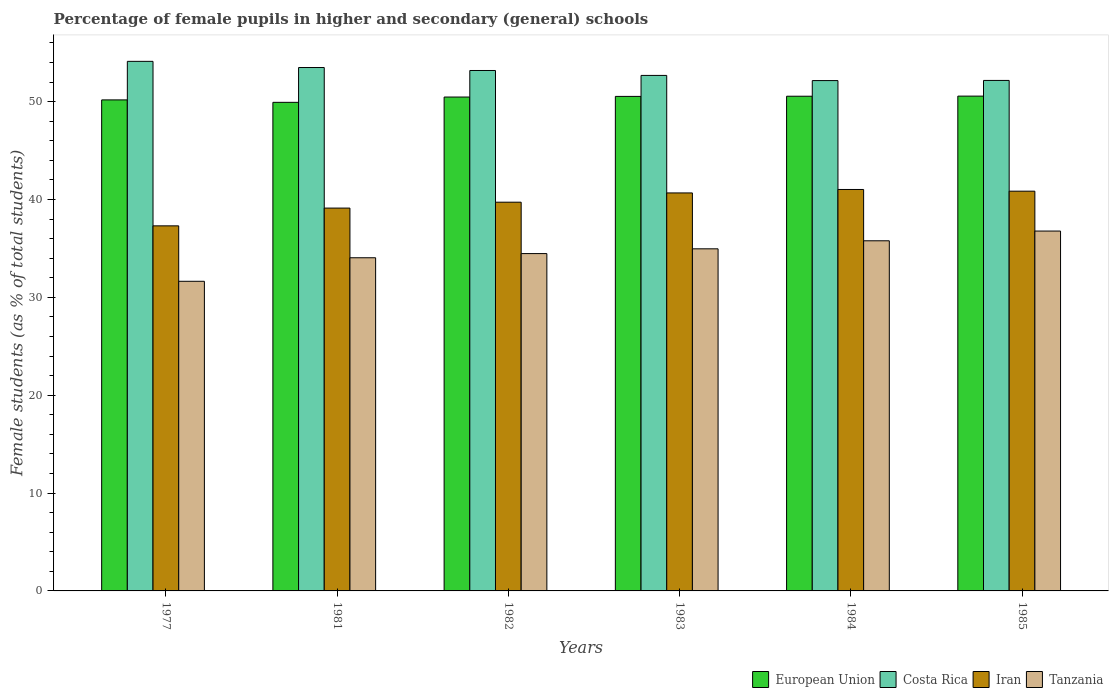How many different coloured bars are there?
Your answer should be very brief. 4. How many groups of bars are there?
Offer a terse response. 6. Are the number of bars on each tick of the X-axis equal?
Your answer should be compact. Yes. How many bars are there on the 6th tick from the right?
Provide a succinct answer. 4. What is the label of the 2nd group of bars from the left?
Keep it short and to the point. 1981. In how many cases, is the number of bars for a given year not equal to the number of legend labels?
Provide a short and direct response. 0. What is the percentage of female pupils in higher and secondary schools in Iran in 1982?
Offer a very short reply. 39.72. Across all years, what is the maximum percentage of female pupils in higher and secondary schools in Costa Rica?
Provide a short and direct response. 54.11. Across all years, what is the minimum percentage of female pupils in higher and secondary schools in Tanzania?
Provide a short and direct response. 31.64. In which year was the percentage of female pupils in higher and secondary schools in Iran maximum?
Your answer should be very brief. 1984. What is the total percentage of female pupils in higher and secondary schools in Costa Rica in the graph?
Offer a very short reply. 317.77. What is the difference between the percentage of female pupils in higher and secondary schools in Tanzania in 1977 and that in 1981?
Your answer should be compact. -2.41. What is the difference between the percentage of female pupils in higher and secondary schools in Costa Rica in 1985 and the percentage of female pupils in higher and secondary schools in Iran in 1984?
Ensure brevity in your answer.  11.14. What is the average percentage of female pupils in higher and secondary schools in Costa Rica per year?
Provide a succinct answer. 52.96. In the year 1981, what is the difference between the percentage of female pupils in higher and secondary schools in European Union and percentage of female pupils in higher and secondary schools in Iran?
Your response must be concise. 10.81. What is the ratio of the percentage of female pupils in higher and secondary schools in Iran in 1982 to that in 1985?
Offer a terse response. 0.97. Is the percentage of female pupils in higher and secondary schools in Iran in 1981 less than that in 1985?
Your answer should be very brief. Yes. Is the difference between the percentage of female pupils in higher and secondary schools in European Union in 1981 and 1985 greater than the difference between the percentage of female pupils in higher and secondary schools in Iran in 1981 and 1985?
Keep it short and to the point. Yes. What is the difference between the highest and the second highest percentage of female pupils in higher and secondary schools in Iran?
Offer a very short reply. 0.17. What is the difference between the highest and the lowest percentage of female pupils in higher and secondary schools in European Union?
Give a very brief answer. 0.63. In how many years, is the percentage of female pupils in higher and secondary schools in Iran greater than the average percentage of female pupils in higher and secondary schools in Iran taken over all years?
Make the answer very short. 3. Is the sum of the percentage of female pupils in higher and secondary schools in Costa Rica in 1983 and 1985 greater than the maximum percentage of female pupils in higher and secondary schools in Tanzania across all years?
Provide a short and direct response. Yes. What does the 3rd bar from the left in 1981 represents?
Your answer should be compact. Iran. What does the 1st bar from the right in 1982 represents?
Ensure brevity in your answer.  Tanzania. Is it the case that in every year, the sum of the percentage of female pupils in higher and secondary schools in Costa Rica and percentage of female pupils in higher and secondary schools in Iran is greater than the percentage of female pupils in higher and secondary schools in European Union?
Keep it short and to the point. Yes. Are all the bars in the graph horizontal?
Provide a short and direct response. No. What is the difference between two consecutive major ticks on the Y-axis?
Your answer should be very brief. 10. Are the values on the major ticks of Y-axis written in scientific E-notation?
Provide a succinct answer. No. Does the graph contain grids?
Provide a short and direct response. No. How many legend labels are there?
Offer a terse response. 4. How are the legend labels stacked?
Your answer should be compact. Horizontal. What is the title of the graph?
Offer a terse response. Percentage of female pupils in higher and secondary (general) schools. Does "Romania" appear as one of the legend labels in the graph?
Provide a succinct answer. No. What is the label or title of the Y-axis?
Ensure brevity in your answer.  Female students (as % of total students). What is the Female students (as % of total students) of European Union in 1977?
Your answer should be very brief. 50.18. What is the Female students (as % of total students) in Costa Rica in 1977?
Your response must be concise. 54.11. What is the Female students (as % of total students) of Iran in 1977?
Give a very brief answer. 37.3. What is the Female students (as % of total students) in Tanzania in 1977?
Offer a terse response. 31.64. What is the Female students (as % of total students) in European Union in 1981?
Provide a short and direct response. 49.93. What is the Female students (as % of total students) of Costa Rica in 1981?
Offer a terse response. 53.48. What is the Female students (as % of total students) of Iran in 1981?
Make the answer very short. 39.12. What is the Female students (as % of total students) in Tanzania in 1981?
Ensure brevity in your answer.  34.04. What is the Female students (as % of total students) in European Union in 1982?
Provide a succinct answer. 50.47. What is the Female students (as % of total students) of Costa Rica in 1982?
Your answer should be compact. 53.18. What is the Female students (as % of total students) of Iran in 1982?
Your answer should be very brief. 39.72. What is the Female students (as % of total students) in Tanzania in 1982?
Offer a terse response. 34.47. What is the Female students (as % of total students) of European Union in 1983?
Offer a very short reply. 50.53. What is the Female students (as % of total students) of Costa Rica in 1983?
Keep it short and to the point. 52.68. What is the Female students (as % of total students) in Iran in 1983?
Offer a terse response. 40.67. What is the Female students (as % of total students) of Tanzania in 1983?
Provide a succinct answer. 34.96. What is the Female students (as % of total students) of European Union in 1984?
Offer a very short reply. 50.55. What is the Female students (as % of total students) in Costa Rica in 1984?
Your answer should be very brief. 52.15. What is the Female students (as % of total students) of Iran in 1984?
Ensure brevity in your answer.  41.02. What is the Female students (as % of total students) in Tanzania in 1984?
Your answer should be very brief. 35.78. What is the Female students (as % of total students) of European Union in 1985?
Your answer should be very brief. 50.56. What is the Female students (as % of total students) of Costa Rica in 1985?
Keep it short and to the point. 52.16. What is the Female students (as % of total students) of Iran in 1985?
Provide a succinct answer. 40.85. What is the Female students (as % of total students) of Tanzania in 1985?
Your response must be concise. 36.77. Across all years, what is the maximum Female students (as % of total students) in European Union?
Provide a short and direct response. 50.56. Across all years, what is the maximum Female students (as % of total students) in Costa Rica?
Keep it short and to the point. 54.11. Across all years, what is the maximum Female students (as % of total students) in Iran?
Keep it short and to the point. 41.02. Across all years, what is the maximum Female students (as % of total students) in Tanzania?
Give a very brief answer. 36.77. Across all years, what is the minimum Female students (as % of total students) in European Union?
Your response must be concise. 49.93. Across all years, what is the minimum Female students (as % of total students) of Costa Rica?
Keep it short and to the point. 52.15. Across all years, what is the minimum Female students (as % of total students) of Iran?
Provide a short and direct response. 37.3. Across all years, what is the minimum Female students (as % of total students) in Tanzania?
Make the answer very short. 31.64. What is the total Female students (as % of total students) in European Union in the graph?
Ensure brevity in your answer.  302.22. What is the total Female students (as % of total students) of Costa Rica in the graph?
Make the answer very short. 317.77. What is the total Female students (as % of total students) in Iran in the graph?
Your response must be concise. 238.68. What is the total Female students (as % of total students) in Tanzania in the graph?
Keep it short and to the point. 207.67. What is the difference between the Female students (as % of total students) in European Union in 1977 and that in 1981?
Provide a short and direct response. 0.25. What is the difference between the Female students (as % of total students) of Costa Rica in 1977 and that in 1981?
Make the answer very short. 0.63. What is the difference between the Female students (as % of total students) of Iran in 1977 and that in 1981?
Your answer should be very brief. -1.82. What is the difference between the Female students (as % of total students) in Tanzania in 1977 and that in 1981?
Give a very brief answer. -2.41. What is the difference between the Female students (as % of total students) in European Union in 1977 and that in 1982?
Provide a succinct answer. -0.29. What is the difference between the Female students (as % of total students) of Costa Rica in 1977 and that in 1982?
Your answer should be compact. 0.93. What is the difference between the Female students (as % of total students) of Iran in 1977 and that in 1982?
Provide a succinct answer. -2.42. What is the difference between the Female students (as % of total students) of Tanzania in 1977 and that in 1982?
Offer a terse response. -2.83. What is the difference between the Female students (as % of total students) of European Union in 1977 and that in 1983?
Provide a short and direct response. -0.36. What is the difference between the Female students (as % of total students) in Costa Rica in 1977 and that in 1983?
Provide a short and direct response. 1.44. What is the difference between the Female students (as % of total students) in Iran in 1977 and that in 1983?
Offer a very short reply. -3.36. What is the difference between the Female students (as % of total students) of Tanzania in 1977 and that in 1983?
Your answer should be very brief. -3.32. What is the difference between the Female students (as % of total students) of European Union in 1977 and that in 1984?
Your answer should be compact. -0.38. What is the difference between the Female students (as % of total students) in Costa Rica in 1977 and that in 1984?
Provide a succinct answer. 1.96. What is the difference between the Female students (as % of total students) of Iran in 1977 and that in 1984?
Make the answer very short. -3.72. What is the difference between the Female students (as % of total students) in Tanzania in 1977 and that in 1984?
Your response must be concise. -4.14. What is the difference between the Female students (as % of total students) in European Union in 1977 and that in 1985?
Offer a very short reply. -0.39. What is the difference between the Female students (as % of total students) of Costa Rica in 1977 and that in 1985?
Offer a very short reply. 1.95. What is the difference between the Female students (as % of total students) in Iran in 1977 and that in 1985?
Ensure brevity in your answer.  -3.54. What is the difference between the Female students (as % of total students) of Tanzania in 1977 and that in 1985?
Your response must be concise. -5.13. What is the difference between the Female students (as % of total students) in European Union in 1981 and that in 1982?
Ensure brevity in your answer.  -0.54. What is the difference between the Female students (as % of total students) in Costa Rica in 1981 and that in 1982?
Ensure brevity in your answer.  0.3. What is the difference between the Female students (as % of total students) in Iran in 1981 and that in 1982?
Ensure brevity in your answer.  -0.6. What is the difference between the Female students (as % of total students) in Tanzania in 1981 and that in 1982?
Offer a terse response. -0.43. What is the difference between the Female students (as % of total students) in European Union in 1981 and that in 1983?
Provide a succinct answer. -0.61. What is the difference between the Female students (as % of total students) of Costa Rica in 1981 and that in 1983?
Offer a very short reply. 0.81. What is the difference between the Female students (as % of total students) in Iran in 1981 and that in 1983?
Your answer should be very brief. -1.55. What is the difference between the Female students (as % of total students) of Tanzania in 1981 and that in 1983?
Give a very brief answer. -0.91. What is the difference between the Female students (as % of total students) of European Union in 1981 and that in 1984?
Make the answer very short. -0.62. What is the difference between the Female students (as % of total students) of Costa Rica in 1981 and that in 1984?
Give a very brief answer. 1.33. What is the difference between the Female students (as % of total students) in Iran in 1981 and that in 1984?
Offer a terse response. -1.9. What is the difference between the Female students (as % of total students) in Tanzania in 1981 and that in 1984?
Your answer should be very brief. -1.73. What is the difference between the Female students (as % of total students) in European Union in 1981 and that in 1985?
Make the answer very short. -0.63. What is the difference between the Female students (as % of total students) in Costa Rica in 1981 and that in 1985?
Give a very brief answer. 1.32. What is the difference between the Female students (as % of total students) in Iran in 1981 and that in 1985?
Make the answer very short. -1.73. What is the difference between the Female students (as % of total students) of Tanzania in 1981 and that in 1985?
Your response must be concise. -2.73. What is the difference between the Female students (as % of total students) in European Union in 1982 and that in 1983?
Offer a terse response. -0.07. What is the difference between the Female students (as % of total students) in Costa Rica in 1982 and that in 1983?
Your answer should be compact. 0.5. What is the difference between the Female students (as % of total students) of Iran in 1982 and that in 1983?
Make the answer very short. -0.95. What is the difference between the Female students (as % of total students) of Tanzania in 1982 and that in 1983?
Make the answer very short. -0.49. What is the difference between the Female students (as % of total students) of European Union in 1982 and that in 1984?
Ensure brevity in your answer.  -0.08. What is the difference between the Female students (as % of total students) of Costa Rica in 1982 and that in 1984?
Provide a succinct answer. 1.03. What is the difference between the Female students (as % of total students) in Iran in 1982 and that in 1984?
Give a very brief answer. -1.3. What is the difference between the Female students (as % of total students) of Tanzania in 1982 and that in 1984?
Provide a short and direct response. -1.31. What is the difference between the Female students (as % of total students) of European Union in 1982 and that in 1985?
Offer a very short reply. -0.09. What is the difference between the Female students (as % of total students) in Costa Rica in 1982 and that in 1985?
Provide a succinct answer. 1.02. What is the difference between the Female students (as % of total students) in Iran in 1982 and that in 1985?
Your answer should be very brief. -1.12. What is the difference between the Female students (as % of total students) of Tanzania in 1982 and that in 1985?
Provide a short and direct response. -2.3. What is the difference between the Female students (as % of total students) of European Union in 1983 and that in 1984?
Keep it short and to the point. -0.02. What is the difference between the Female students (as % of total students) of Costa Rica in 1983 and that in 1984?
Provide a short and direct response. 0.53. What is the difference between the Female students (as % of total students) of Iran in 1983 and that in 1984?
Your answer should be very brief. -0.35. What is the difference between the Female students (as % of total students) in Tanzania in 1983 and that in 1984?
Your response must be concise. -0.82. What is the difference between the Female students (as % of total students) of European Union in 1983 and that in 1985?
Ensure brevity in your answer.  -0.03. What is the difference between the Female students (as % of total students) in Costa Rica in 1983 and that in 1985?
Your response must be concise. 0.51. What is the difference between the Female students (as % of total students) of Iran in 1983 and that in 1985?
Provide a succinct answer. -0.18. What is the difference between the Female students (as % of total students) in Tanzania in 1983 and that in 1985?
Ensure brevity in your answer.  -1.82. What is the difference between the Female students (as % of total students) in European Union in 1984 and that in 1985?
Provide a succinct answer. -0.01. What is the difference between the Female students (as % of total students) in Costa Rica in 1984 and that in 1985?
Ensure brevity in your answer.  -0.01. What is the difference between the Female students (as % of total students) of Iran in 1984 and that in 1985?
Your answer should be compact. 0.17. What is the difference between the Female students (as % of total students) in Tanzania in 1984 and that in 1985?
Provide a short and direct response. -0.99. What is the difference between the Female students (as % of total students) in European Union in 1977 and the Female students (as % of total students) in Costa Rica in 1981?
Give a very brief answer. -3.31. What is the difference between the Female students (as % of total students) in European Union in 1977 and the Female students (as % of total students) in Iran in 1981?
Offer a very short reply. 11.06. What is the difference between the Female students (as % of total students) of European Union in 1977 and the Female students (as % of total students) of Tanzania in 1981?
Offer a terse response. 16.13. What is the difference between the Female students (as % of total students) in Costa Rica in 1977 and the Female students (as % of total students) in Iran in 1981?
Make the answer very short. 14.99. What is the difference between the Female students (as % of total students) of Costa Rica in 1977 and the Female students (as % of total students) of Tanzania in 1981?
Ensure brevity in your answer.  20.07. What is the difference between the Female students (as % of total students) in Iran in 1977 and the Female students (as % of total students) in Tanzania in 1981?
Offer a very short reply. 3.26. What is the difference between the Female students (as % of total students) in European Union in 1977 and the Female students (as % of total students) in Costa Rica in 1982?
Offer a very short reply. -3. What is the difference between the Female students (as % of total students) in European Union in 1977 and the Female students (as % of total students) in Iran in 1982?
Your response must be concise. 10.45. What is the difference between the Female students (as % of total students) of European Union in 1977 and the Female students (as % of total students) of Tanzania in 1982?
Give a very brief answer. 15.71. What is the difference between the Female students (as % of total students) of Costa Rica in 1977 and the Female students (as % of total students) of Iran in 1982?
Provide a succinct answer. 14.39. What is the difference between the Female students (as % of total students) in Costa Rica in 1977 and the Female students (as % of total students) in Tanzania in 1982?
Your response must be concise. 19.64. What is the difference between the Female students (as % of total students) of Iran in 1977 and the Female students (as % of total students) of Tanzania in 1982?
Give a very brief answer. 2.83. What is the difference between the Female students (as % of total students) of European Union in 1977 and the Female students (as % of total students) of Costa Rica in 1983?
Keep it short and to the point. -2.5. What is the difference between the Female students (as % of total students) in European Union in 1977 and the Female students (as % of total students) in Iran in 1983?
Provide a succinct answer. 9.51. What is the difference between the Female students (as % of total students) in European Union in 1977 and the Female students (as % of total students) in Tanzania in 1983?
Your response must be concise. 15.22. What is the difference between the Female students (as % of total students) of Costa Rica in 1977 and the Female students (as % of total students) of Iran in 1983?
Offer a terse response. 13.45. What is the difference between the Female students (as % of total students) of Costa Rica in 1977 and the Female students (as % of total students) of Tanzania in 1983?
Ensure brevity in your answer.  19.16. What is the difference between the Female students (as % of total students) of Iran in 1977 and the Female students (as % of total students) of Tanzania in 1983?
Your answer should be very brief. 2.35. What is the difference between the Female students (as % of total students) in European Union in 1977 and the Female students (as % of total students) in Costa Rica in 1984?
Make the answer very short. -1.97. What is the difference between the Female students (as % of total students) of European Union in 1977 and the Female students (as % of total students) of Iran in 1984?
Give a very brief answer. 9.15. What is the difference between the Female students (as % of total students) in European Union in 1977 and the Female students (as % of total students) in Tanzania in 1984?
Provide a short and direct response. 14.4. What is the difference between the Female students (as % of total students) in Costa Rica in 1977 and the Female students (as % of total students) in Iran in 1984?
Give a very brief answer. 13.09. What is the difference between the Female students (as % of total students) in Costa Rica in 1977 and the Female students (as % of total students) in Tanzania in 1984?
Provide a short and direct response. 18.34. What is the difference between the Female students (as % of total students) in Iran in 1977 and the Female students (as % of total students) in Tanzania in 1984?
Your answer should be compact. 1.53. What is the difference between the Female students (as % of total students) in European Union in 1977 and the Female students (as % of total students) in Costa Rica in 1985?
Ensure brevity in your answer.  -1.99. What is the difference between the Female students (as % of total students) of European Union in 1977 and the Female students (as % of total students) of Iran in 1985?
Your answer should be compact. 9.33. What is the difference between the Female students (as % of total students) in European Union in 1977 and the Female students (as % of total students) in Tanzania in 1985?
Ensure brevity in your answer.  13.4. What is the difference between the Female students (as % of total students) in Costa Rica in 1977 and the Female students (as % of total students) in Iran in 1985?
Ensure brevity in your answer.  13.27. What is the difference between the Female students (as % of total students) in Costa Rica in 1977 and the Female students (as % of total students) in Tanzania in 1985?
Your answer should be compact. 17.34. What is the difference between the Female students (as % of total students) in Iran in 1977 and the Female students (as % of total students) in Tanzania in 1985?
Keep it short and to the point. 0.53. What is the difference between the Female students (as % of total students) of European Union in 1981 and the Female students (as % of total students) of Costa Rica in 1982?
Your answer should be compact. -3.25. What is the difference between the Female students (as % of total students) in European Union in 1981 and the Female students (as % of total students) in Iran in 1982?
Give a very brief answer. 10.2. What is the difference between the Female students (as % of total students) in European Union in 1981 and the Female students (as % of total students) in Tanzania in 1982?
Make the answer very short. 15.46. What is the difference between the Female students (as % of total students) of Costa Rica in 1981 and the Female students (as % of total students) of Iran in 1982?
Your answer should be very brief. 13.76. What is the difference between the Female students (as % of total students) in Costa Rica in 1981 and the Female students (as % of total students) in Tanzania in 1982?
Offer a terse response. 19.01. What is the difference between the Female students (as % of total students) in Iran in 1981 and the Female students (as % of total students) in Tanzania in 1982?
Your response must be concise. 4.65. What is the difference between the Female students (as % of total students) of European Union in 1981 and the Female students (as % of total students) of Costa Rica in 1983?
Provide a succinct answer. -2.75. What is the difference between the Female students (as % of total students) in European Union in 1981 and the Female students (as % of total students) in Iran in 1983?
Offer a terse response. 9.26. What is the difference between the Female students (as % of total students) of European Union in 1981 and the Female students (as % of total students) of Tanzania in 1983?
Your answer should be compact. 14.97. What is the difference between the Female students (as % of total students) of Costa Rica in 1981 and the Female students (as % of total students) of Iran in 1983?
Your answer should be very brief. 12.82. What is the difference between the Female students (as % of total students) of Costa Rica in 1981 and the Female students (as % of total students) of Tanzania in 1983?
Provide a succinct answer. 18.53. What is the difference between the Female students (as % of total students) in Iran in 1981 and the Female students (as % of total students) in Tanzania in 1983?
Ensure brevity in your answer.  4.16. What is the difference between the Female students (as % of total students) in European Union in 1981 and the Female students (as % of total students) in Costa Rica in 1984?
Offer a very short reply. -2.22. What is the difference between the Female students (as % of total students) of European Union in 1981 and the Female students (as % of total students) of Iran in 1984?
Offer a very short reply. 8.91. What is the difference between the Female students (as % of total students) of European Union in 1981 and the Female students (as % of total students) of Tanzania in 1984?
Keep it short and to the point. 14.15. What is the difference between the Female students (as % of total students) of Costa Rica in 1981 and the Female students (as % of total students) of Iran in 1984?
Keep it short and to the point. 12.46. What is the difference between the Female students (as % of total students) in Costa Rica in 1981 and the Female students (as % of total students) in Tanzania in 1984?
Offer a very short reply. 17.71. What is the difference between the Female students (as % of total students) of Iran in 1981 and the Female students (as % of total students) of Tanzania in 1984?
Your answer should be compact. 3.34. What is the difference between the Female students (as % of total students) in European Union in 1981 and the Female students (as % of total students) in Costa Rica in 1985?
Offer a terse response. -2.24. What is the difference between the Female students (as % of total students) in European Union in 1981 and the Female students (as % of total students) in Iran in 1985?
Give a very brief answer. 9.08. What is the difference between the Female students (as % of total students) in European Union in 1981 and the Female students (as % of total students) in Tanzania in 1985?
Your answer should be very brief. 13.15. What is the difference between the Female students (as % of total students) in Costa Rica in 1981 and the Female students (as % of total students) in Iran in 1985?
Keep it short and to the point. 12.64. What is the difference between the Female students (as % of total students) of Costa Rica in 1981 and the Female students (as % of total students) of Tanzania in 1985?
Provide a succinct answer. 16.71. What is the difference between the Female students (as % of total students) of Iran in 1981 and the Female students (as % of total students) of Tanzania in 1985?
Provide a short and direct response. 2.35. What is the difference between the Female students (as % of total students) in European Union in 1982 and the Female students (as % of total students) in Costa Rica in 1983?
Give a very brief answer. -2.21. What is the difference between the Female students (as % of total students) of European Union in 1982 and the Female students (as % of total students) of Iran in 1983?
Your answer should be very brief. 9.8. What is the difference between the Female students (as % of total students) in European Union in 1982 and the Female students (as % of total students) in Tanzania in 1983?
Provide a succinct answer. 15.51. What is the difference between the Female students (as % of total students) of Costa Rica in 1982 and the Female students (as % of total students) of Iran in 1983?
Your answer should be very brief. 12.51. What is the difference between the Female students (as % of total students) in Costa Rica in 1982 and the Female students (as % of total students) in Tanzania in 1983?
Provide a short and direct response. 18.22. What is the difference between the Female students (as % of total students) of Iran in 1982 and the Female students (as % of total students) of Tanzania in 1983?
Your answer should be very brief. 4.76. What is the difference between the Female students (as % of total students) of European Union in 1982 and the Female students (as % of total students) of Costa Rica in 1984?
Ensure brevity in your answer.  -1.68. What is the difference between the Female students (as % of total students) in European Union in 1982 and the Female students (as % of total students) in Iran in 1984?
Provide a short and direct response. 9.45. What is the difference between the Female students (as % of total students) in European Union in 1982 and the Female students (as % of total students) in Tanzania in 1984?
Your response must be concise. 14.69. What is the difference between the Female students (as % of total students) in Costa Rica in 1982 and the Female students (as % of total students) in Iran in 1984?
Provide a short and direct response. 12.16. What is the difference between the Female students (as % of total students) in Costa Rica in 1982 and the Female students (as % of total students) in Tanzania in 1984?
Provide a short and direct response. 17.4. What is the difference between the Female students (as % of total students) in Iran in 1982 and the Female students (as % of total students) in Tanzania in 1984?
Offer a terse response. 3.94. What is the difference between the Female students (as % of total students) of European Union in 1982 and the Female students (as % of total students) of Costa Rica in 1985?
Give a very brief answer. -1.7. What is the difference between the Female students (as % of total students) in European Union in 1982 and the Female students (as % of total students) in Iran in 1985?
Give a very brief answer. 9.62. What is the difference between the Female students (as % of total students) of European Union in 1982 and the Female students (as % of total students) of Tanzania in 1985?
Your answer should be compact. 13.69. What is the difference between the Female students (as % of total students) of Costa Rica in 1982 and the Female students (as % of total students) of Iran in 1985?
Give a very brief answer. 12.33. What is the difference between the Female students (as % of total students) of Costa Rica in 1982 and the Female students (as % of total students) of Tanzania in 1985?
Ensure brevity in your answer.  16.41. What is the difference between the Female students (as % of total students) of Iran in 1982 and the Female students (as % of total students) of Tanzania in 1985?
Your answer should be very brief. 2.95. What is the difference between the Female students (as % of total students) in European Union in 1983 and the Female students (as % of total students) in Costa Rica in 1984?
Your answer should be very brief. -1.62. What is the difference between the Female students (as % of total students) in European Union in 1983 and the Female students (as % of total students) in Iran in 1984?
Offer a very short reply. 9.51. What is the difference between the Female students (as % of total students) of European Union in 1983 and the Female students (as % of total students) of Tanzania in 1984?
Keep it short and to the point. 14.75. What is the difference between the Female students (as % of total students) of Costa Rica in 1983 and the Female students (as % of total students) of Iran in 1984?
Your answer should be compact. 11.66. What is the difference between the Female students (as % of total students) in Costa Rica in 1983 and the Female students (as % of total students) in Tanzania in 1984?
Provide a short and direct response. 16.9. What is the difference between the Female students (as % of total students) in Iran in 1983 and the Female students (as % of total students) in Tanzania in 1984?
Provide a succinct answer. 4.89. What is the difference between the Female students (as % of total students) of European Union in 1983 and the Female students (as % of total students) of Costa Rica in 1985?
Ensure brevity in your answer.  -1.63. What is the difference between the Female students (as % of total students) of European Union in 1983 and the Female students (as % of total students) of Iran in 1985?
Keep it short and to the point. 9.69. What is the difference between the Female students (as % of total students) of European Union in 1983 and the Female students (as % of total students) of Tanzania in 1985?
Offer a terse response. 13.76. What is the difference between the Female students (as % of total students) in Costa Rica in 1983 and the Female students (as % of total students) in Iran in 1985?
Make the answer very short. 11.83. What is the difference between the Female students (as % of total students) of Costa Rica in 1983 and the Female students (as % of total students) of Tanzania in 1985?
Offer a terse response. 15.9. What is the difference between the Female students (as % of total students) in Iran in 1983 and the Female students (as % of total students) in Tanzania in 1985?
Make the answer very short. 3.9. What is the difference between the Female students (as % of total students) in European Union in 1984 and the Female students (as % of total students) in Costa Rica in 1985?
Give a very brief answer. -1.61. What is the difference between the Female students (as % of total students) of European Union in 1984 and the Female students (as % of total students) of Iran in 1985?
Provide a succinct answer. 9.7. What is the difference between the Female students (as % of total students) in European Union in 1984 and the Female students (as % of total students) in Tanzania in 1985?
Your answer should be very brief. 13.78. What is the difference between the Female students (as % of total students) of Costa Rica in 1984 and the Female students (as % of total students) of Iran in 1985?
Your response must be concise. 11.3. What is the difference between the Female students (as % of total students) in Costa Rica in 1984 and the Female students (as % of total students) in Tanzania in 1985?
Your answer should be compact. 15.38. What is the difference between the Female students (as % of total students) in Iran in 1984 and the Female students (as % of total students) in Tanzania in 1985?
Keep it short and to the point. 4.25. What is the average Female students (as % of total students) of European Union per year?
Provide a succinct answer. 50.37. What is the average Female students (as % of total students) in Costa Rica per year?
Keep it short and to the point. 52.96. What is the average Female students (as % of total students) of Iran per year?
Keep it short and to the point. 39.78. What is the average Female students (as % of total students) of Tanzania per year?
Your answer should be very brief. 34.61. In the year 1977, what is the difference between the Female students (as % of total students) of European Union and Female students (as % of total students) of Costa Rica?
Give a very brief answer. -3.94. In the year 1977, what is the difference between the Female students (as % of total students) in European Union and Female students (as % of total students) in Iran?
Make the answer very short. 12.87. In the year 1977, what is the difference between the Female students (as % of total students) in European Union and Female students (as % of total students) in Tanzania?
Make the answer very short. 18.54. In the year 1977, what is the difference between the Female students (as % of total students) of Costa Rica and Female students (as % of total students) of Iran?
Provide a succinct answer. 16.81. In the year 1977, what is the difference between the Female students (as % of total students) in Costa Rica and Female students (as % of total students) in Tanzania?
Your response must be concise. 22.47. In the year 1977, what is the difference between the Female students (as % of total students) of Iran and Female students (as % of total students) of Tanzania?
Provide a succinct answer. 5.66. In the year 1981, what is the difference between the Female students (as % of total students) in European Union and Female students (as % of total students) in Costa Rica?
Keep it short and to the point. -3.56. In the year 1981, what is the difference between the Female students (as % of total students) of European Union and Female students (as % of total students) of Iran?
Ensure brevity in your answer.  10.81. In the year 1981, what is the difference between the Female students (as % of total students) of European Union and Female students (as % of total students) of Tanzania?
Offer a very short reply. 15.88. In the year 1981, what is the difference between the Female students (as % of total students) in Costa Rica and Female students (as % of total students) in Iran?
Provide a short and direct response. 14.36. In the year 1981, what is the difference between the Female students (as % of total students) of Costa Rica and Female students (as % of total students) of Tanzania?
Your answer should be compact. 19.44. In the year 1981, what is the difference between the Female students (as % of total students) in Iran and Female students (as % of total students) in Tanzania?
Offer a very short reply. 5.08. In the year 1982, what is the difference between the Female students (as % of total students) of European Union and Female students (as % of total students) of Costa Rica?
Your answer should be compact. -2.71. In the year 1982, what is the difference between the Female students (as % of total students) of European Union and Female students (as % of total students) of Iran?
Give a very brief answer. 10.74. In the year 1982, what is the difference between the Female students (as % of total students) in European Union and Female students (as % of total students) in Tanzania?
Offer a terse response. 16. In the year 1982, what is the difference between the Female students (as % of total students) in Costa Rica and Female students (as % of total students) in Iran?
Give a very brief answer. 13.46. In the year 1982, what is the difference between the Female students (as % of total students) of Costa Rica and Female students (as % of total students) of Tanzania?
Give a very brief answer. 18.71. In the year 1982, what is the difference between the Female students (as % of total students) in Iran and Female students (as % of total students) in Tanzania?
Offer a terse response. 5.25. In the year 1983, what is the difference between the Female students (as % of total students) in European Union and Female students (as % of total students) in Costa Rica?
Your response must be concise. -2.14. In the year 1983, what is the difference between the Female students (as % of total students) of European Union and Female students (as % of total students) of Iran?
Provide a short and direct response. 9.86. In the year 1983, what is the difference between the Female students (as % of total students) in European Union and Female students (as % of total students) in Tanzania?
Your answer should be very brief. 15.57. In the year 1983, what is the difference between the Female students (as % of total students) of Costa Rica and Female students (as % of total students) of Iran?
Offer a terse response. 12.01. In the year 1983, what is the difference between the Female students (as % of total students) of Costa Rica and Female students (as % of total students) of Tanzania?
Your answer should be very brief. 17.72. In the year 1983, what is the difference between the Female students (as % of total students) in Iran and Female students (as % of total students) in Tanzania?
Provide a succinct answer. 5.71. In the year 1984, what is the difference between the Female students (as % of total students) of European Union and Female students (as % of total students) of Costa Rica?
Offer a terse response. -1.6. In the year 1984, what is the difference between the Female students (as % of total students) of European Union and Female students (as % of total students) of Iran?
Offer a very short reply. 9.53. In the year 1984, what is the difference between the Female students (as % of total students) in European Union and Female students (as % of total students) in Tanzania?
Give a very brief answer. 14.77. In the year 1984, what is the difference between the Female students (as % of total students) in Costa Rica and Female students (as % of total students) in Iran?
Offer a terse response. 11.13. In the year 1984, what is the difference between the Female students (as % of total students) in Costa Rica and Female students (as % of total students) in Tanzania?
Give a very brief answer. 16.37. In the year 1984, what is the difference between the Female students (as % of total students) of Iran and Female students (as % of total students) of Tanzania?
Offer a very short reply. 5.24. In the year 1985, what is the difference between the Female students (as % of total students) of European Union and Female students (as % of total students) of Costa Rica?
Keep it short and to the point. -1.6. In the year 1985, what is the difference between the Female students (as % of total students) in European Union and Female students (as % of total students) in Iran?
Your answer should be compact. 9.71. In the year 1985, what is the difference between the Female students (as % of total students) of European Union and Female students (as % of total students) of Tanzania?
Give a very brief answer. 13.79. In the year 1985, what is the difference between the Female students (as % of total students) of Costa Rica and Female students (as % of total students) of Iran?
Keep it short and to the point. 11.32. In the year 1985, what is the difference between the Female students (as % of total students) in Costa Rica and Female students (as % of total students) in Tanzania?
Your answer should be compact. 15.39. In the year 1985, what is the difference between the Female students (as % of total students) of Iran and Female students (as % of total students) of Tanzania?
Provide a succinct answer. 4.07. What is the ratio of the Female students (as % of total students) of Costa Rica in 1977 to that in 1981?
Keep it short and to the point. 1.01. What is the ratio of the Female students (as % of total students) in Iran in 1977 to that in 1981?
Keep it short and to the point. 0.95. What is the ratio of the Female students (as % of total students) in Tanzania in 1977 to that in 1981?
Ensure brevity in your answer.  0.93. What is the ratio of the Female students (as % of total students) in European Union in 1977 to that in 1982?
Give a very brief answer. 0.99. What is the ratio of the Female students (as % of total students) of Costa Rica in 1977 to that in 1982?
Provide a short and direct response. 1.02. What is the ratio of the Female students (as % of total students) of Iran in 1977 to that in 1982?
Keep it short and to the point. 0.94. What is the ratio of the Female students (as % of total students) of Tanzania in 1977 to that in 1982?
Provide a succinct answer. 0.92. What is the ratio of the Female students (as % of total students) in Costa Rica in 1977 to that in 1983?
Offer a very short reply. 1.03. What is the ratio of the Female students (as % of total students) in Iran in 1977 to that in 1983?
Your answer should be very brief. 0.92. What is the ratio of the Female students (as % of total students) of Tanzania in 1977 to that in 1983?
Provide a short and direct response. 0.91. What is the ratio of the Female students (as % of total students) in European Union in 1977 to that in 1984?
Your response must be concise. 0.99. What is the ratio of the Female students (as % of total students) of Costa Rica in 1977 to that in 1984?
Your response must be concise. 1.04. What is the ratio of the Female students (as % of total students) in Iran in 1977 to that in 1984?
Keep it short and to the point. 0.91. What is the ratio of the Female students (as % of total students) in Tanzania in 1977 to that in 1984?
Offer a terse response. 0.88. What is the ratio of the Female students (as % of total students) in European Union in 1977 to that in 1985?
Offer a very short reply. 0.99. What is the ratio of the Female students (as % of total students) of Costa Rica in 1977 to that in 1985?
Your answer should be very brief. 1.04. What is the ratio of the Female students (as % of total students) of Iran in 1977 to that in 1985?
Ensure brevity in your answer.  0.91. What is the ratio of the Female students (as % of total students) in Tanzania in 1977 to that in 1985?
Your response must be concise. 0.86. What is the ratio of the Female students (as % of total students) in European Union in 1981 to that in 1982?
Provide a short and direct response. 0.99. What is the ratio of the Female students (as % of total students) of Costa Rica in 1981 to that in 1982?
Provide a succinct answer. 1.01. What is the ratio of the Female students (as % of total students) of Tanzania in 1981 to that in 1982?
Your answer should be very brief. 0.99. What is the ratio of the Female students (as % of total students) of European Union in 1981 to that in 1983?
Offer a very short reply. 0.99. What is the ratio of the Female students (as % of total students) in Costa Rica in 1981 to that in 1983?
Offer a very short reply. 1.02. What is the ratio of the Female students (as % of total students) of Iran in 1981 to that in 1983?
Keep it short and to the point. 0.96. What is the ratio of the Female students (as % of total students) of Tanzania in 1981 to that in 1983?
Ensure brevity in your answer.  0.97. What is the ratio of the Female students (as % of total students) in Costa Rica in 1981 to that in 1984?
Give a very brief answer. 1.03. What is the ratio of the Female students (as % of total students) in Iran in 1981 to that in 1984?
Provide a succinct answer. 0.95. What is the ratio of the Female students (as % of total students) of Tanzania in 1981 to that in 1984?
Provide a short and direct response. 0.95. What is the ratio of the Female students (as % of total students) of European Union in 1981 to that in 1985?
Provide a short and direct response. 0.99. What is the ratio of the Female students (as % of total students) in Costa Rica in 1981 to that in 1985?
Provide a short and direct response. 1.03. What is the ratio of the Female students (as % of total students) of Iran in 1981 to that in 1985?
Your answer should be very brief. 0.96. What is the ratio of the Female students (as % of total students) of Tanzania in 1981 to that in 1985?
Keep it short and to the point. 0.93. What is the ratio of the Female students (as % of total students) of European Union in 1982 to that in 1983?
Your response must be concise. 1. What is the ratio of the Female students (as % of total students) of Costa Rica in 1982 to that in 1983?
Your answer should be very brief. 1.01. What is the ratio of the Female students (as % of total students) in Iran in 1982 to that in 1983?
Give a very brief answer. 0.98. What is the ratio of the Female students (as % of total students) in Tanzania in 1982 to that in 1983?
Your answer should be very brief. 0.99. What is the ratio of the Female students (as % of total students) of Costa Rica in 1982 to that in 1984?
Your answer should be compact. 1.02. What is the ratio of the Female students (as % of total students) in Iran in 1982 to that in 1984?
Offer a very short reply. 0.97. What is the ratio of the Female students (as % of total students) of Tanzania in 1982 to that in 1984?
Your answer should be compact. 0.96. What is the ratio of the Female students (as % of total students) in European Union in 1982 to that in 1985?
Make the answer very short. 1. What is the ratio of the Female students (as % of total students) in Costa Rica in 1982 to that in 1985?
Ensure brevity in your answer.  1.02. What is the ratio of the Female students (as % of total students) of Iran in 1982 to that in 1985?
Offer a very short reply. 0.97. What is the ratio of the Female students (as % of total students) in Tanzania in 1982 to that in 1985?
Your response must be concise. 0.94. What is the ratio of the Female students (as % of total students) of Costa Rica in 1983 to that in 1984?
Offer a very short reply. 1.01. What is the ratio of the Female students (as % of total students) in Iran in 1983 to that in 1984?
Offer a terse response. 0.99. What is the ratio of the Female students (as % of total students) in Tanzania in 1983 to that in 1984?
Offer a terse response. 0.98. What is the ratio of the Female students (as % of total students) in Costa Rica in 1983 to that in 1985?
Provide a succinct answer. 1.01. What is the ratio of the Female students (as % of total students) in Tanzania in 1983 to that in 1985?
Your answer should be compact. 0.95. What is the ratio of the Female students (as % of total students) of Costa Rica in 1984 to that in 1985?
Your answer should be very brief. 1. What is the ratio of the Female students (as % of total students) in Tanzania in 1984 to that in 1985?
Provide a short and direct response. 0.97. What is the difference between the highest and the second highest Female students (as % of total students) of European Union?
Your answer should be compact. 0.01. What is the difference between the highest and the second highest Female students (as % of total students) in Costa Rica?
Give a very brief answer. 0.63. What is the difference between the highest and the second highest Female students (as % of total students) in Iran?
Your answer should be compact. 0.17. What is the difference between the highest and the second highest Female students (as % of total students) in Tanzania?
Provide a succinct answer. 0.99. What is the difference between the highest and the lowest Female students (as % of total students) of European Union?
Offer a terse response. 0.63. What is the difference between the highest and the lowest Female students (as % of total students) in Costa Rica?
Your answer should be very brief. 1.96. What is the difference between the highest and the lowest Female students (as % of total students) in Iran?
Your answer should be compact. 3.72. What is the difference between the highest and the lowest Female students (as % of total students) of Tanzania?
Provide a short and direct response. 5.13. 